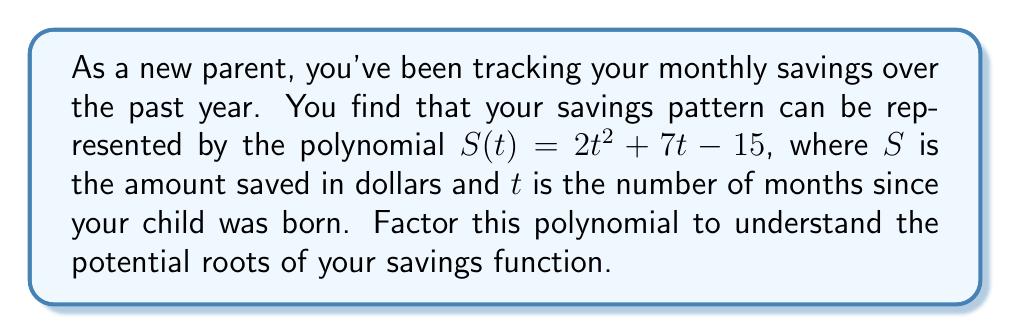Help me with this question. To factor the polynomial $S(t) = 2t^2 + 7t - 15$, we'll follow these steps:

1) First, we need to check if there's a common factor. In this case, there isn't one.

2) Next, we'll use the ac-method to factor this quadratic expression:
   a = 2, b = 7, c = -15

3) Calculate ac: $ac = 2 \times (-15) = -30$

4) Find two numbers that multiply to give -30 and add up to 7:
   These numbers are 10 and -3

5) Rewrite the middle term using these numbers:
   $S(t) = 2t^2 + 10t - 3t - 15$

6) Group the terms:
   $S(t) = (2t^2 + 10t) + (-3t - 15)$

7) Factor out the common factor in each group:
   $S(t) = 2t(t + 5) - 3(t + 5)$

8) Factor out the common binomial $(t + 5)$:
   $S(t) = (t + 5)(2t - 3)$

Thus, we have factored the polynomial into $(t + 5)(2t - 3)$.
Answer: $S(t) = (t + 5)(2t - 3)$ 